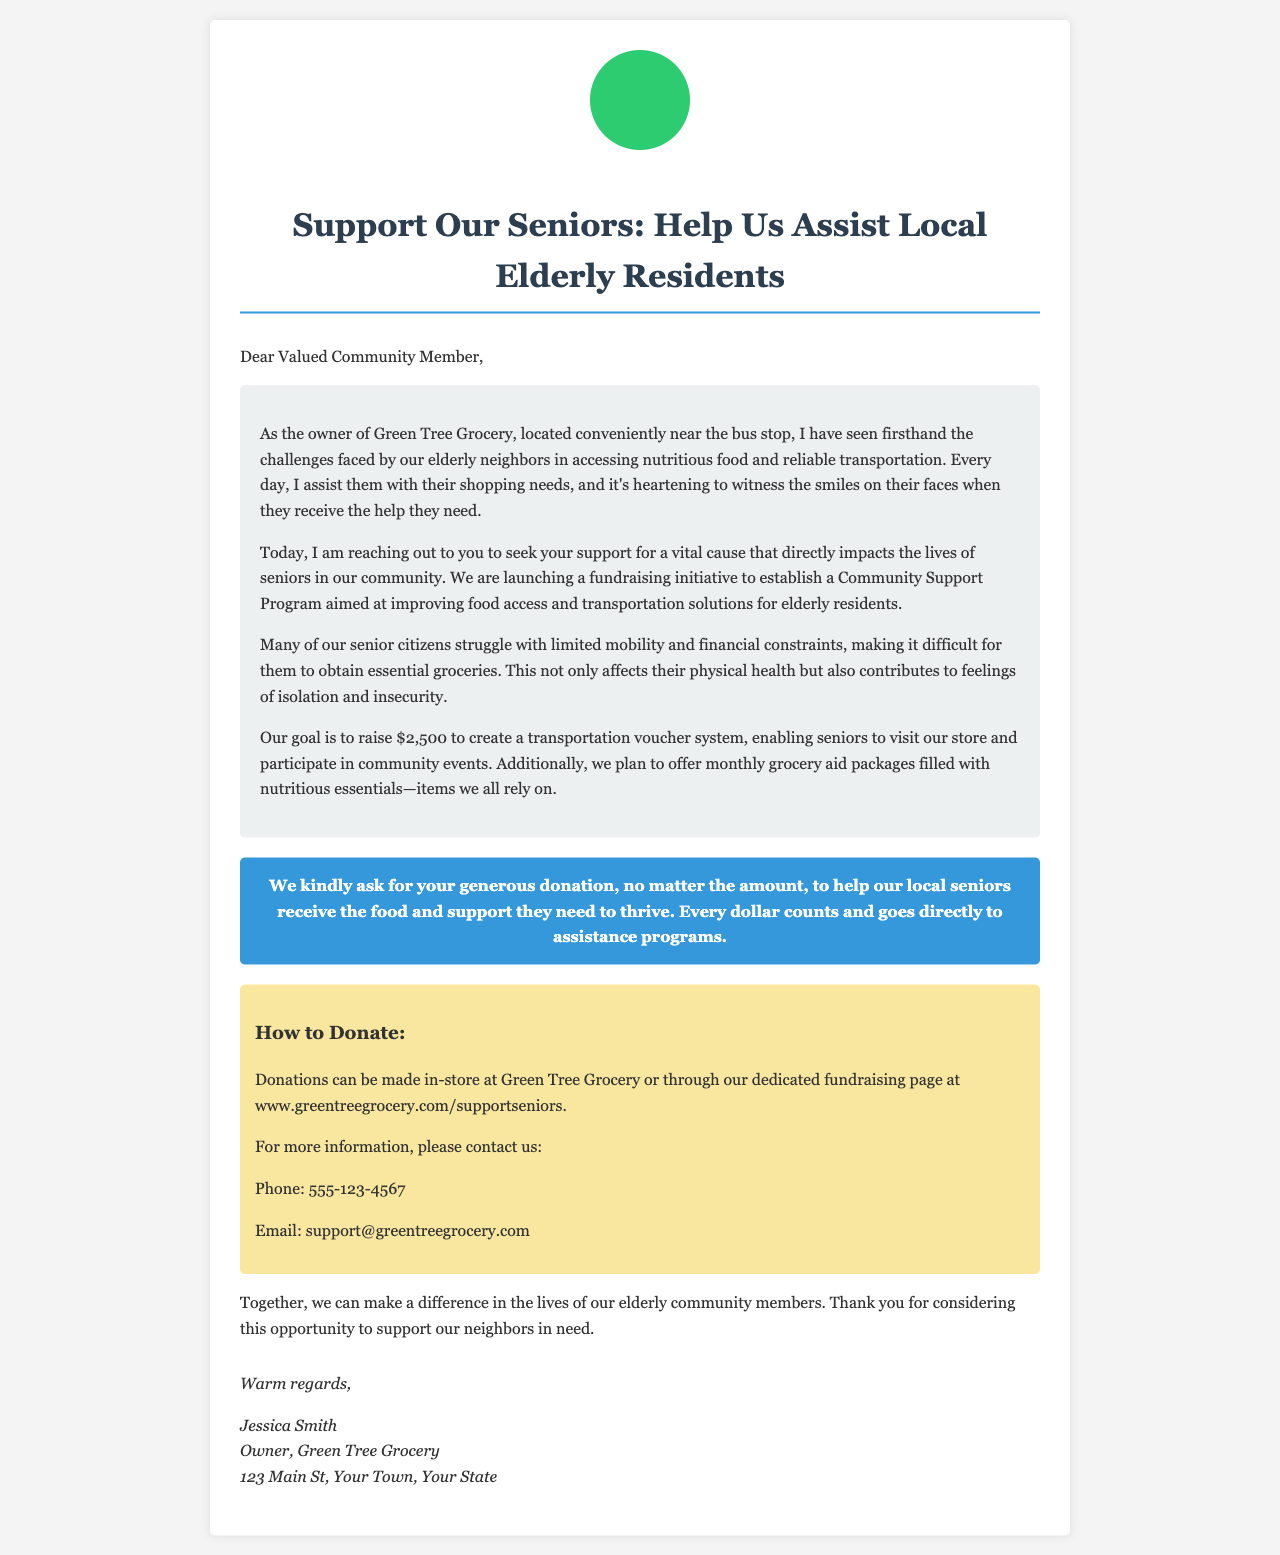What is the fundraising goal? The fundraising goal is explicitly stated in the document, which is to raise $2,500 for the community support program.
Answer: $2,500 What type of assistance is being requested? The document specifies that donations are requested to assist seniors with food access and transportation solutions.
Answer: Food access and transportation Who is the owner of Green Tree Grocery? The document mentions Jessica Smith as the owner of Green Tree Grocery.
Answer: Jessica Smith Where can donations be made? The document includes information on where donations can be made, both in-store and online, specifying a website link.
Answer: Green Tree Grocery or www.greentreegrocery.com/supportseniors What is a consequence of limited mobility for seniors mentioned in the document? The document indicates that limited mobility contributes to feelings of isolation and insecurity among seniors.
Answer: Isolation and insecurity What does the transportation voucher system aim to provide? The document explains that the transportation voucher system is intended to enable seniors to visit the store and participate in community events.
Answer: Visits to the store and community events What is the phone number for more information? The document provides a specific phone number for inquiries related to the fundraising initiative.
Answer: 555-123-4567 What do monthly grocery aid packages include? The document states that the grocery aid packages will be filled with nutritious essentials, which are items all community members rely on.
Answer: Nutritious essentials 